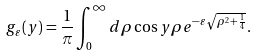<formula> <loc_0><loc_0><loc_500><loc_500>g _ { \varepsilon } ( y ) = \frac { 1 } { \pi } \int _ { 0 } ^ { \infty } d \rho \cos y \rho e ^ { - \varepsilon \sqrt { \rho ^ { 2 } + \frac { 1 } { 4 } } } .</formula> 